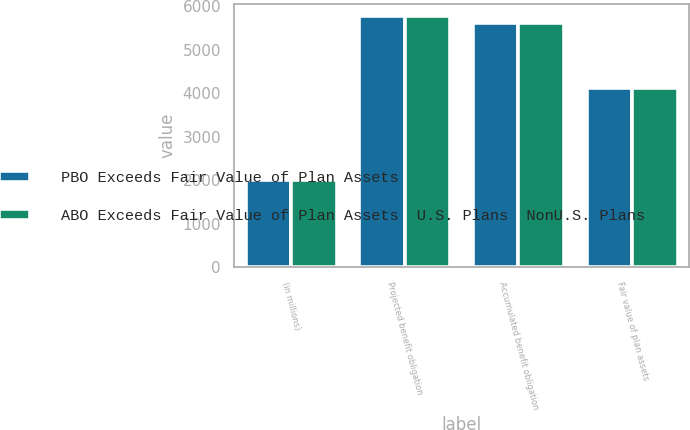<chart> <loc_0><loc_0><loc_500><loc_500><stacked_bar_chart><ecel><fcel>(in millions)<fcel>Projected benefit obligation<fcel>Accumulated benefit obligation<fcel>Fair value of plan assets<nl><fcel>PBO Exceeds Fair Value of Plan Assets<fcel>2014<fcel>5769<fcel>5601<fcel>4111<nl><fcel>ABO Exceeds Fair Value of Plan Assets  U.S. Plans  NonU.S. Plans<fcel>2014<fcel>5769<fcel>5601<fcel>4111<nl></chart> 